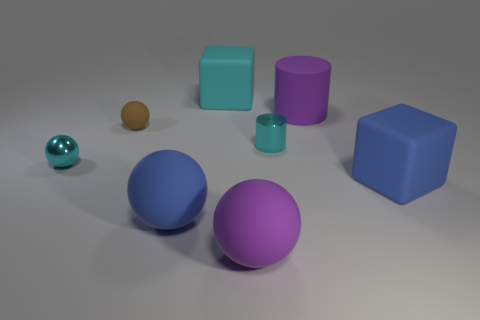Subtract all brown blocks. Subtract all green cylinders. How many blocks are left? 2 Add 1 small cyan things. How many objects exist? 9 Subtract all cylinders. How many objects are left? 6 Add 2 rubber cylinders. How many rubber cylinders are left? 3 Add 2 large red metallic objects. How many large red metallic objects exist? 2 Subtract 1 cyan balls. How many objects are left? 7 Subtract all large purple rubber balls. Subtract all small brown spheres. How many objects are left? 6 